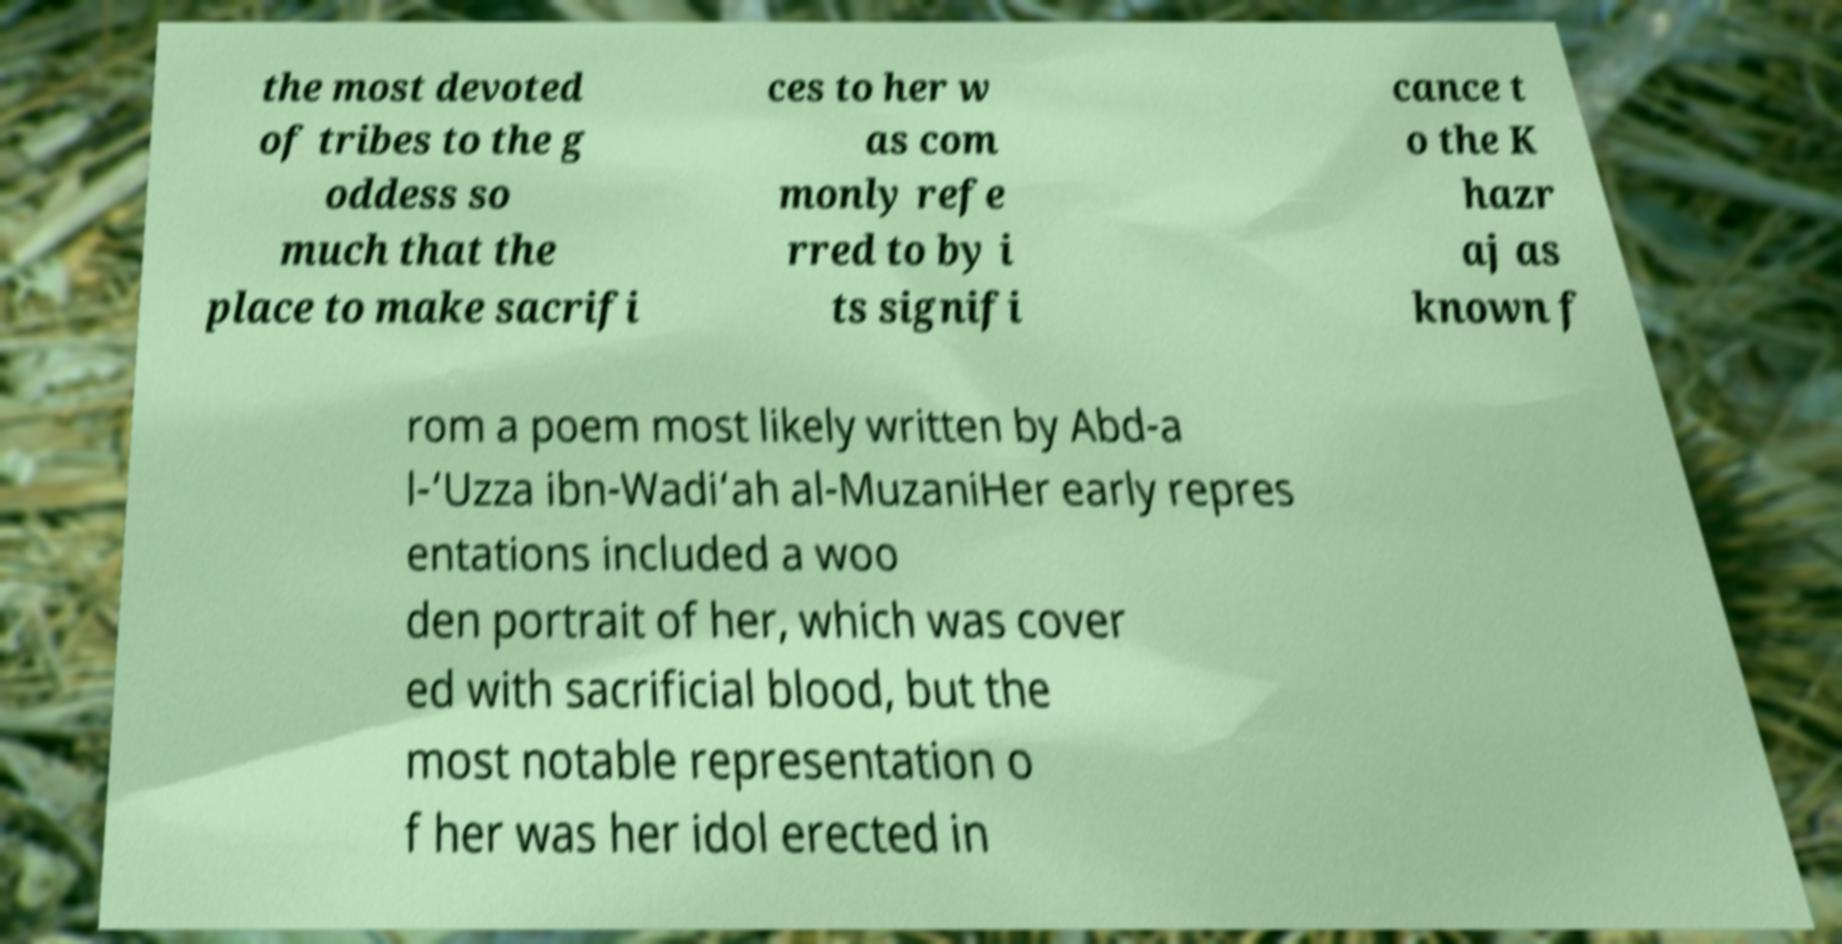I need the written content from this picture converted into text. Can you do that? the most devoted of tribes to the g oddess so much that the place to make sacrifi ces to her w as com monly refe rred to by i ts signifi cance t o the K hazr aj as known f rom a poem most likely written by Abd-a l-‘Uzza ibn-Wadi‘ah al-MuzaniHer early repres entations included a woo den portrait of her, which was cover ed with sacrificial blood, but the most notable representation o f her was her idol erected in 